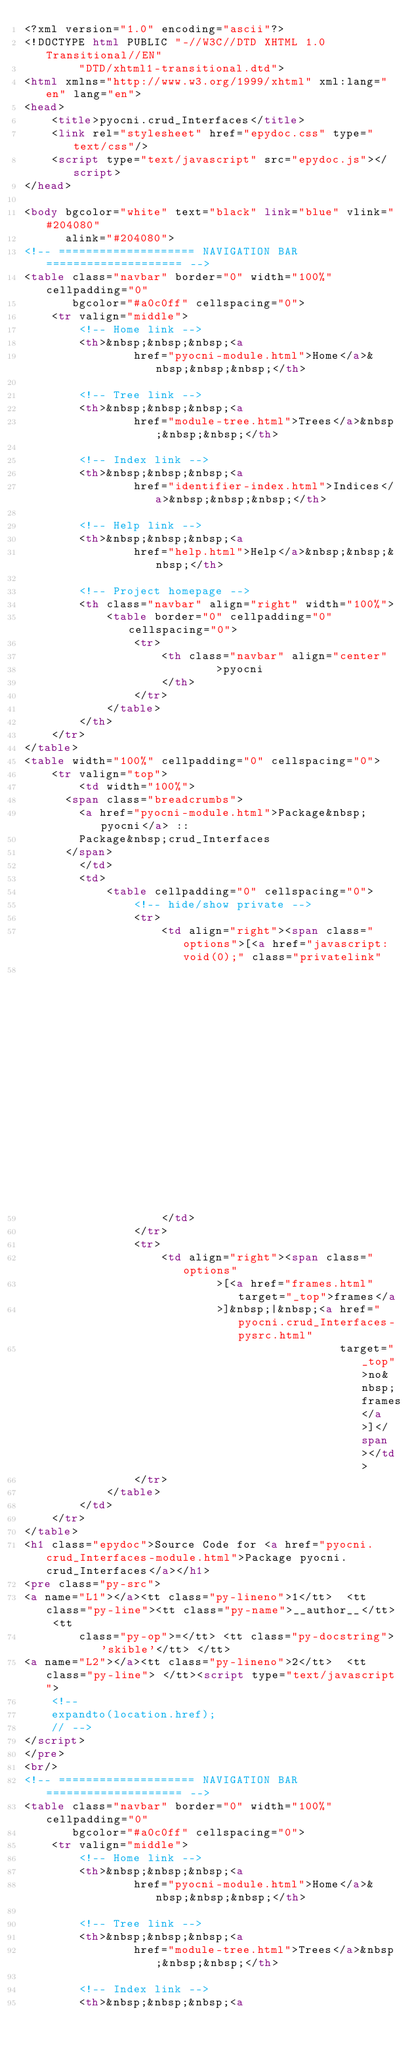Convert code to text. <code><loc_0><loc_0><loc_500><loc_500><_HTML_><?xml version="1.0" encoding="ascii"?>
<!DOCTYPE html PUBLIC "-//W3C//DTD XHTML 1.0 Transitional//EN"
        "DTD/xhtml1-transitional.dtd">
<html xmlns="http://www.w3.org/1999/xhtml" xml:lang="en" lang="en">
<head>
    <title>pyocni.crud_Interfaces</title>
    <link rel="stylesheet" href="epydoc.css" type="text/css"/>
    <script type="text/javascript" src="epydoc.js"></script>
</head>

<body bgcolor="white" text="black" link="blue" vlink="#204080"
      alink="#204080">
<!-- ==================== NAVIGATION BAR ==================== -->
<table class="navbar" border="0" width="100%" cellpadding="0"
       bgcolor="#a0c0ff" cellspacing="0">
    <tr valign="middle">
        <!-- Home link -->
        <th>&nbsp;&nbsp;&nbsp;<a
                href="pyocni-module.html">Home</a>&nbsp;&nbsp;&nbsp;</th>

        <!-- Tree link -->
        <th>&nbsp;&nbsp;&nbsp;<a
                href="module-tree.html">Trees</a>&nbsp;&nbsp;&nbsp;</th>

        <!-- Index link -->
        <th>&nbsp;&nbsp;&nbsp;<a
                href="identifier-index.html">Indices</a>&nbsp;&nbsp;&nbsp;</th>

        <!-- Help link -->
        <th>&nbsp;&nbsp;&nbsp;<a
                href="help.html">Help</a>&nbsp;&nbsp;&nbsp;</th>

        <!-- Project homepage -->
        <th class="navbar" align="right" width="100%">
            <table border="0" cellpadding="0" cellspacing="0">
                <tr>
                    <th class="navbar" align="center"
                            >pyocni
                    </th>
                </tr>
            </table>
        </th>
    </tr>
</table>
<table width="100%" cellpadding="0" cellspacing="0">
    <tr valign="top">
        <td width="100%">
      <span class="breadcrumbs">
        <a href="pyocni-module.html">Package&nbsp;pyocni</a> ::
        Package&nbsp;crud_Interfaces
      </span>
        </td>
        <td>
            <table cellpadding="0" cellspacing="0">
                <!-- hide/show private -->
                <tr>
                    <td align="right"><span class="options">[<a href="javascript:void(0);" class="privatelink"
                                                                onclick="toggle_private();">hide&nbsp;private</a>]</span>
                    </td>
                </tr>
                <tr>
                    <td align="right"><span class="options"
                            >[<a href="frames.html" target="_top">frames</a
                            >]&nbsp;|&nbsp;<a href="pyocni.crud_Interfaces-pysrc.html"
                                              target="_top">no&nbsp;frames</a>]</span></td>
                </tr>
            </table>
        </td>
    </tr>
</table>
<h1 class="epydoc">Source Code for <a href="pyocni.crud_Interfaces-module.html">Package pyocni.crud_Interfaces</a></h1>
<pre class="py-src">
<a name="L1"></a><tt class="py-lineno">1</tt>  <tt class="py-line"><tt class="py-name">__author__</tt> <tt
        class="py-op">=</tt> <tt class="py-docstring">'skible'</tt> </tt>
<a name="L2"></a><tt class="py-lineno">2</tt>  <tt class="py-line"> </tt><script type="text/javascript">
    <!--
    expandto(location.href);
    // -->
</script>
</pre>
<br/>
<!-- ==================== NAVIGATION BAR ==================== -->
<table class="navbar" border="0" width="100%" cellpadding="0"
       bgcolor="#a0c0ff" cellspacing="0">
    <tr valign="middle">
        <!-- Home link -->
        <th>&nbsp;&nbsp;&nbsp;<a
                href="pyocni-module.html">Home</a>&nbsp;&nbsp;&nbsp;</th>

        <!-- Tree link -->
        <th>&nbsp;&nbsp;&nbsp;<a
                href="module-tree.html">Trees</a>&nbsp;&nbsp;&nbsp;</th>

        <!-- Index link -->
        <th>&nbsp;&nbsp;&nbsp;<a</code> 